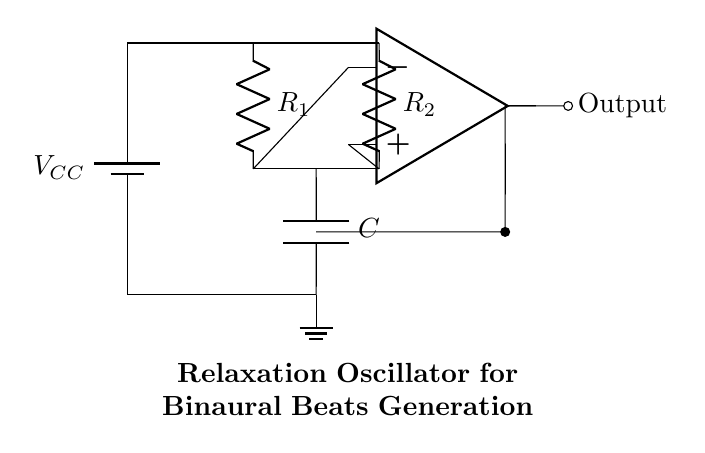What is the type of the oscillator in this circuit? The circuit is a relaxation oscillator, which generates oscillations through a repetitive charging and discharging of the capacitor.
Answer: relaxation oscillator What components are used in the circuit? The circuit includes a power supply, two resistors, a capacitor, and an operational amplifier. These components work together to create the relaxation oscillator.
Answer: power supply, resistors, capacitor, operational amplifier What is the function of the operational amplifier in this circuit? The operational amplifier serves as a comparator that helps in determining the output state of the oscillator based on the voltage across the capacitor.
Answer: comparator Which components are in series in the circuit? The resistors are in series with the capacitor, forming a path for current to flow through. This configuration is essential for the charging and discharging process.
Answer: resistors and capacitor What is the role of the capacitor in this oscillator? The capacitor stores electrical energy and determines the oscillation frequency by charging and discharging over time. This behavior is critical for generating the desired time-based output.
Answer: stores energy What is the output type of this circuit? The output of this relaxation oscillator circuit is an analog signal that can vary over time, usually in the form of a square wave that can be used for sound generation.
Answer: analog What does the symbol at the bottom left represent? The symbol in the bottom left corner represents the ground connection, which serves as a common reference point for the circuit voltage.
Answer: ground 